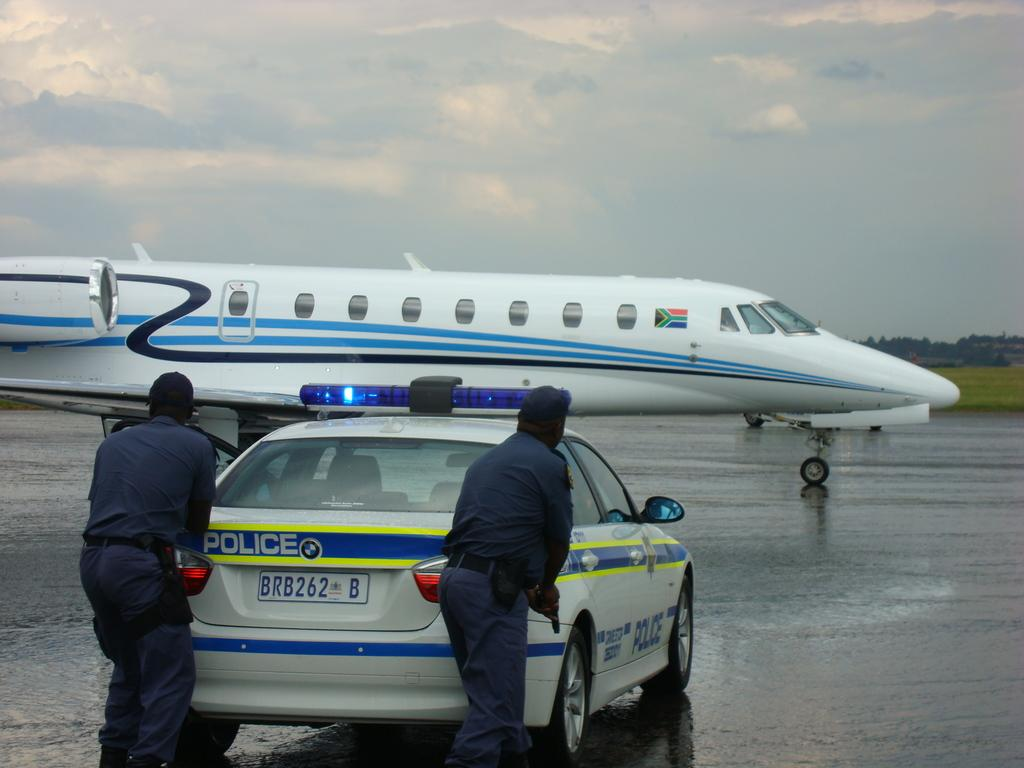How many people are in the image? There are two men standing in the image. What are the men wearing? The men are wearing clothes. What type of terrain is visible in the image? There is grass visible in the image. What mode of transportation can be seen in the image? There is an airplane in the image. What type of pathway is present in the image? There is a road in the image. What type of vegetation is present in the image? There are trees in the image. What is the weather like in the image? The sky is cloudy in the image. Where is the grandmother standing in the image? There is no grandmother present in the image. What type of surface is the daughter walking on in the image? There is no daughter present in the image. 